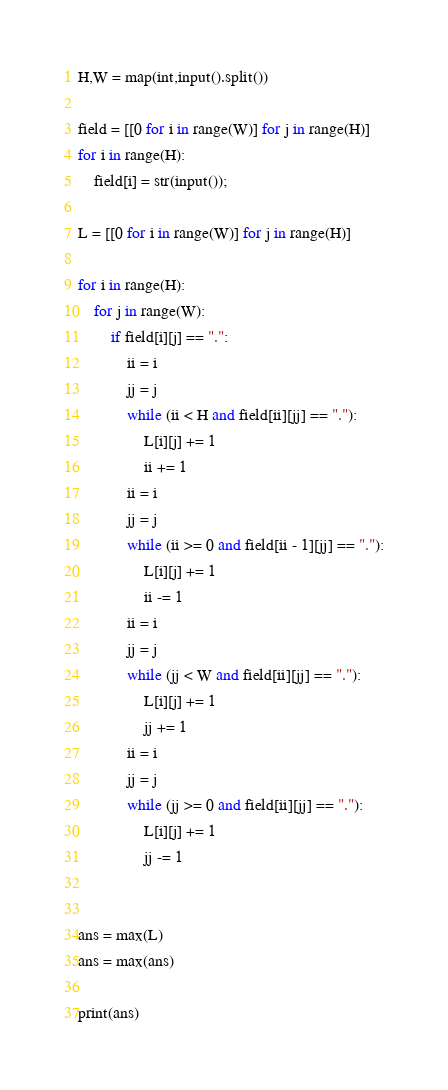Convert code to text. <code><loc_0><loc_0><loc_500><loc_500><_Python_>H,W = map(int,input().split())

field = [[0 for i in range(W)] for j in range(H)]
for i in range(H):
    field[i] = str(input());

L = [[0 for i in range(W)] for j in range(H)]

for i in range(H):
    for j in range(W):
        if field[i][j] == ".":
            ii = i
            jj = j
            while (ii < H and field[ii][jj] == "."):
                L[i][j] += 1
                ii += 1
            ii = i
            jj = j
            while (ii >= 0 and field[ii - 1][jj] == "."):
                L[i][j] += 1
                ii -= 1
            ii = i
            jj = j
            while (jj < W and field[ii][jj] == "."):
                L[i][j] += 1
                jj += 1
            ii = i
            jj = j
            while (jj >= 0 and field[ii][jj] == "."):
                L[i][j] += 1
                jj -= 1


ans = max(L)
ans = max(ans)

print(ans)
</code> 